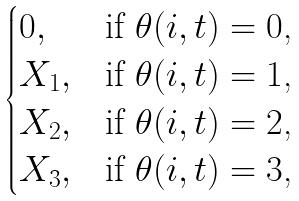<formula> <loc_0><loc_0><loc_500><loc_500>\begin{cases} 0 , & \text {if $\theta(i,t)=0$,} \\ X _ { 1 } , & \text {if $\theta(i,t)=1$,} \\ X _ { 2 } , & \text {if $\theta(i,t)=2$,} \\ X _ { 3 } , & \text {if $\theta(i,t)=3$,} \end{cases}</formula> 